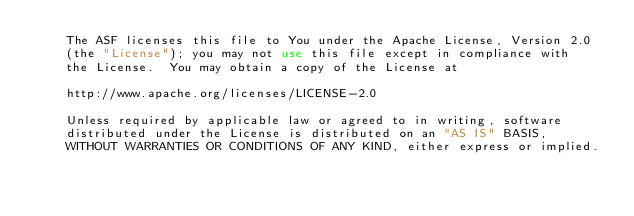Convert code to text. <code><loc_0><loc_0><loc_500><loc_500><_XML_>    The ASF licenses this file to You under the Apache License, Version 2.0
    (the "License"); you may not use this file except in compliance with
    the License.  You may obtain a copy of the License at

    http://www.apache.org/licenses/LICENSE-2.0

    Unless required by applicable law or agreed to in writing, software
    distributed under the License is distributed on an "AS IS" BASIS,
    WITHOUT WARRANTIES OR CONDITIONS OF ANY KIND, either express or implied.</code> 